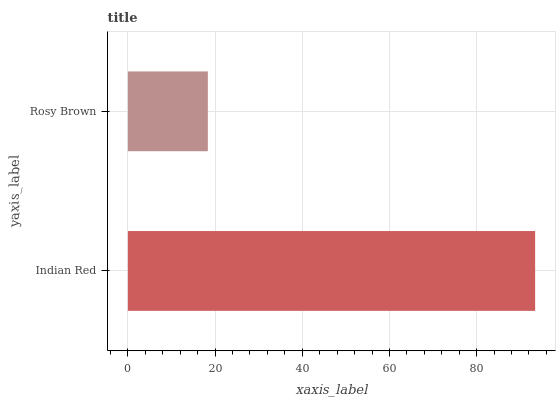Is Rosy Brown the minimum?
Answer yes or no. Yes. Is Indian Red the maximum?
Answer yes or no. Yes. Is Rosy Brown the maximum?
Answer yes or no. No. Is Indian Red greater than Rosy Brown?
Answer yes or no. Yes. Is Rosy Brown less than Indian Red?
Answer yes or no. Yes. Is Rosy Brown greater than Indian Red?
Answer yes or no. No. Is Indian Red less than Rosy Brown?
Answer yes or no. No. Is Indian Red the high median?
Answer yes or no. Yes. Is Rosy Brown the low median?
Answer yes or no. Yes. Is Rosy Brown the high median?
Answer yes or no. No. Is Indian Red the low median?
Answer yes or no. No. 